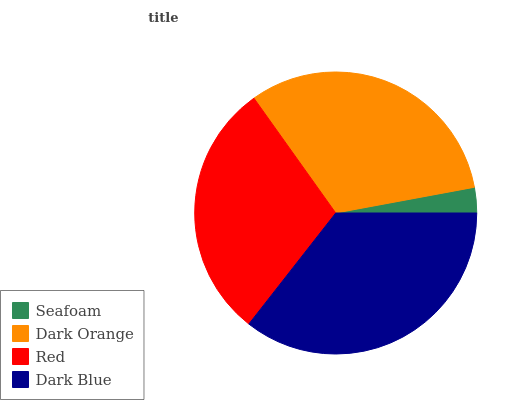Is Seafoam the minimum?
Answer yes or no. Yes. Is Dark Blue the maximum?
Answer yes or no. Yes. Is Dark Orange the minimum?
Answer yes or no. No. Is Dark Orange the maximum?
Answer yes or no. No. Is Dark Orange greater than Seafoam?
Answer yes or no. Yes. Is Seafoam less than Dark Orange?
Answer yes or no. Yes. Is Seafoam greater than Dark Orange?
Answer yes or no. No. Is Dark Orange less than Seafoam?
Answer yes or no. No. Is Dark Orange the high median?
Answer yes or no. Yes. Is Red the low median?
Answer yes or no. Yes. Is Dark Blue the high median?
Answer yes or no. No. Is Dark Blue the low median?
Answer yes or no. No. 